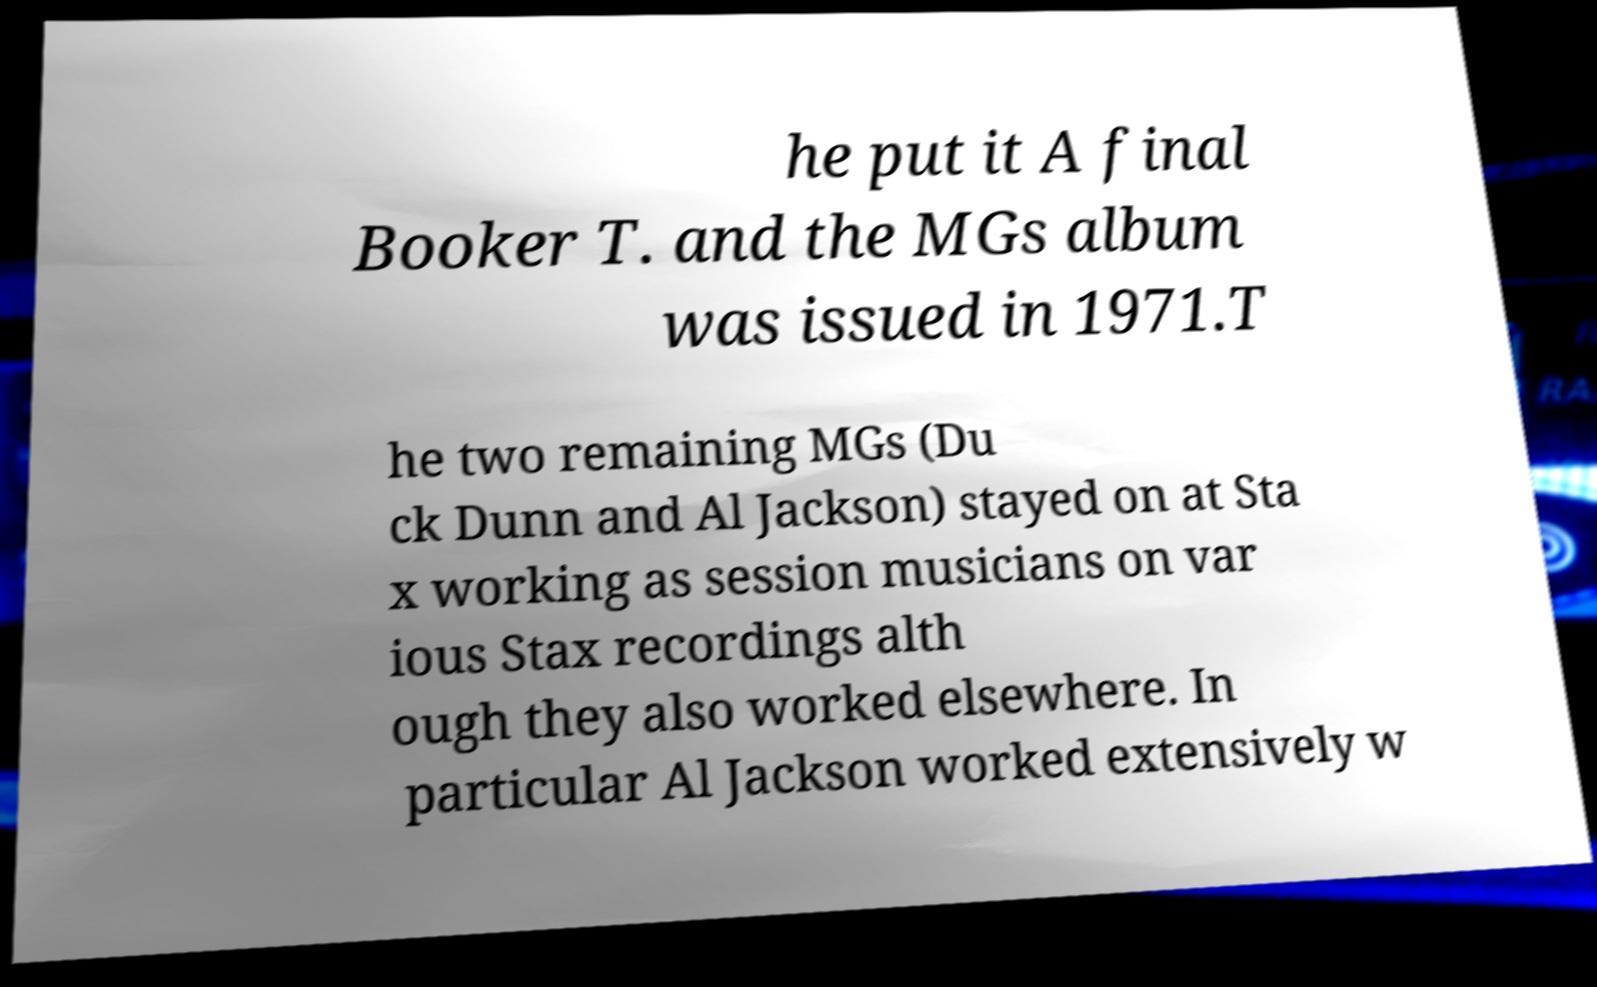Can you read and provide the text displayed in the image?This photo seems to have some interesting text. Can you extract and type it out for me? he put it A final Booker T. and the MGs album was issued in 1971.T he two remaining MGs (Du ck Dunn and Al Jackson) stayed on at Sta x working as session musicians on var ious Stax recordings alth ough they also worked elsewhere. In particular Al Jackson worked extensively w 